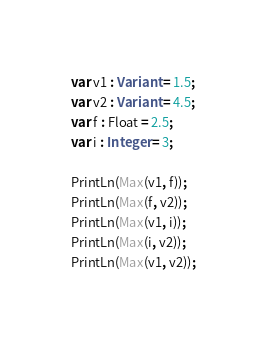<code> <loc_0><loc_0><loc_500><loc_500><_Pascal_>var v1 : Variant = 1.5;
var v2 : Variant = 4.5;
var f : Float = 2.5;
var i : Integer = 3;

PrintLn(Max(v1, f));
PrintLn(Max(f, v2));
PrintLn(Max(v1, i));
PrintLn(Max(i, v2));
PrintLn(Max(v1, v2));</code> 